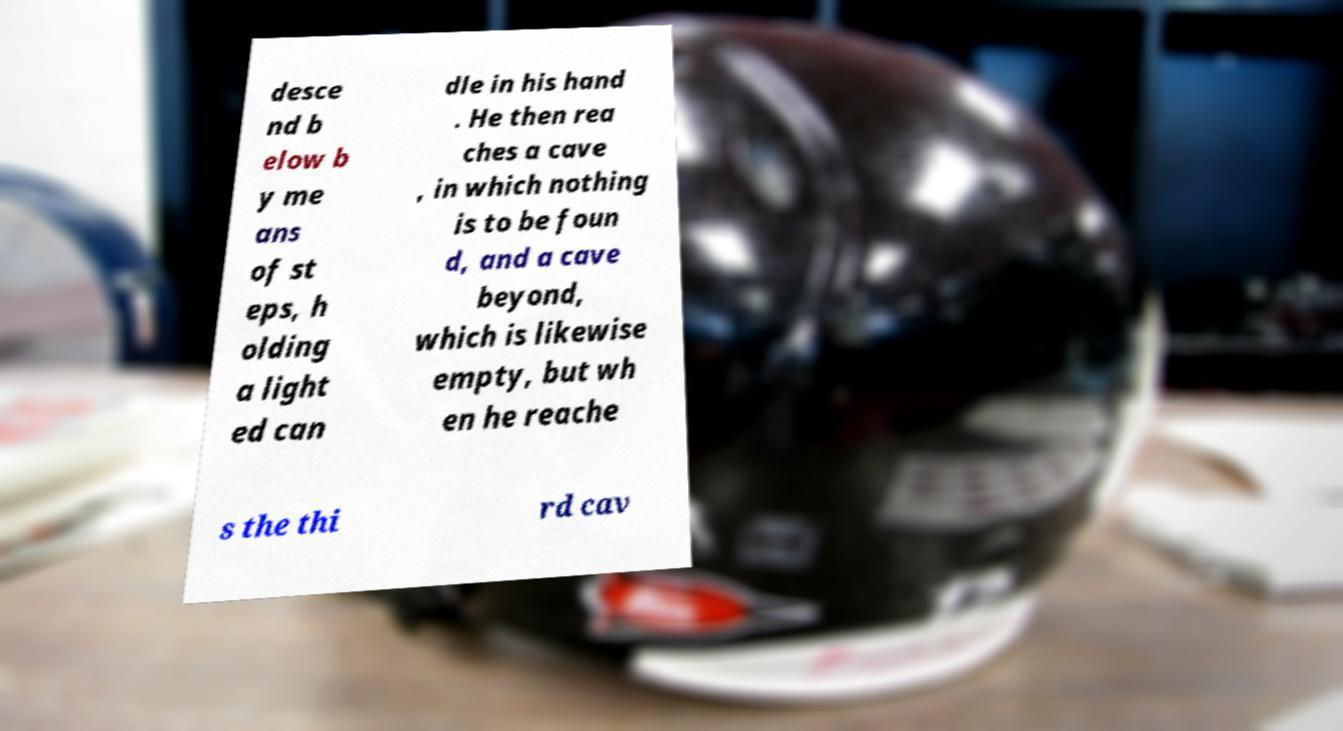What messages or text are displayed in this image? I need them in a readable, typed format. desce nd b elow b y me ans of st eps, h olding a light ed can dle in his hand . He then rea ches a cave , in which nothing is to be foun d, and a cave beyond, which is likewise empty, but wh en he reache s the thi rd cav 